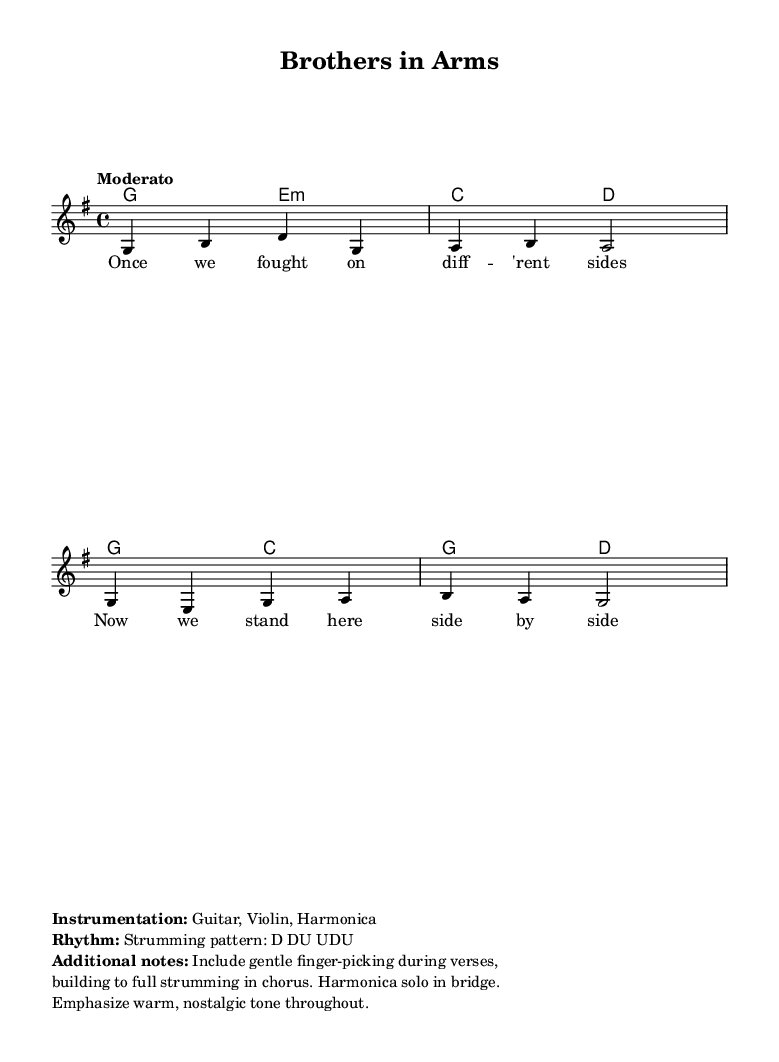What is the key signature of this music? The key signature shown in the sheet music is G major, which has one sharp (F#). This is indicated at the beginning of the staff before the notes start.
Answer: G major What is the time signature of this piece? The time signature is 4/4, meaning there are four beats in each measure and the quarter note receives one beat. This is noted at the beginning of the score.
Answer: 4/4 What is the tempo marking for this song? The tempo marking in the sheet music states "Moderato," indicating a moderate speed for the performance. This can be found at the beginning of the score, right after the time signature.
Answer: Moderato How many measures are in the melody section? By counting the measures in the melody part, one can see there are four distinct measures presented. Each measure is separated by a vertical line on the staff.
Answer: 4 What instrumentation is noted for this piece? The instrumentation specified in the markup section lists Guitar, Violin, and Harmonica as the instruments for this song. This is mentioned after the score details.
Answer: Guitar, Violin, Harmonica Which chord is played during the first measure? The first measure features a G major chord, as indicated by the chord name under the melody. This is identified by looking at the chord mode section.
Answer: G What is the strumming pattern indicated for guitar? The strumming pattern described in the additional notes section reads D DU UDU, clarifying the rhythm that the guitar should follow. This is noted in the markup part below the score.
Answer: D DU UDU 